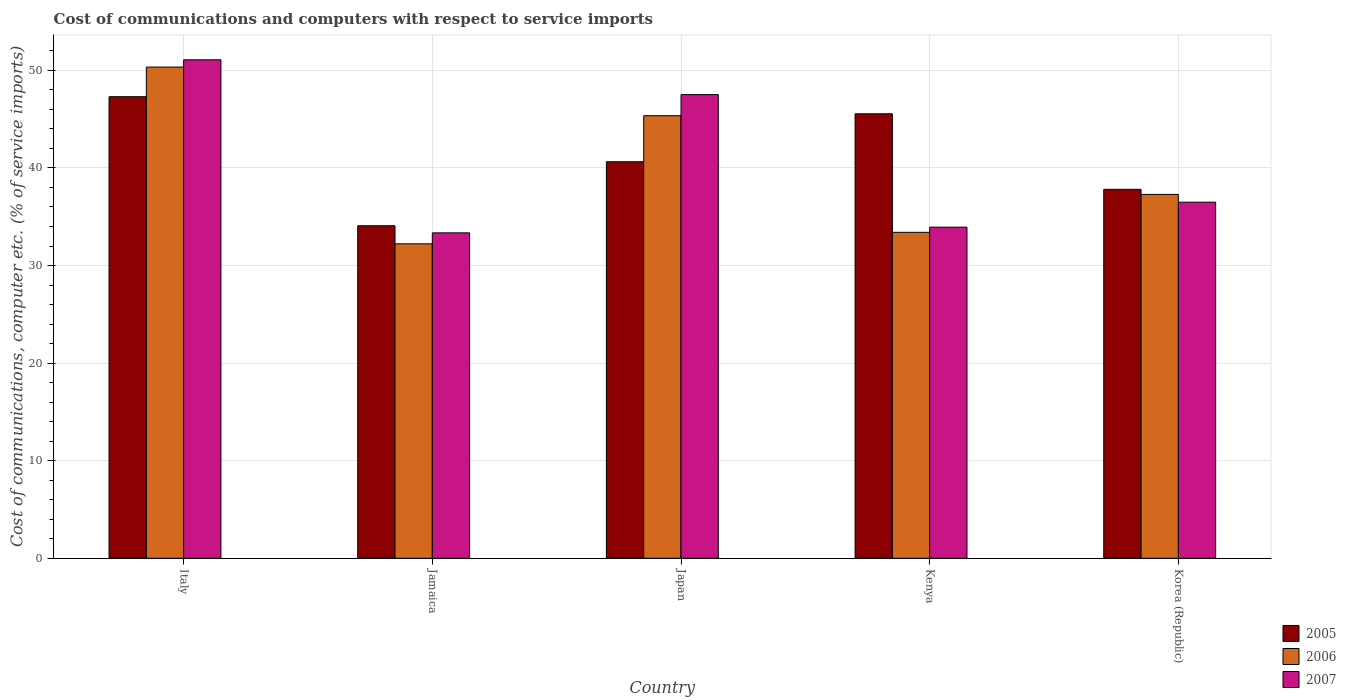Are the number of bars per tick equal to the number of legend labels?
Provide a short and direct response. Yes. How many bars are there on the 2nd tick from the left?
Your answer should be compact. 3. How many bars are there on the 4th tick from the right?
Your response must be concise. 3. What is the label of the 2nd group of bars from the left?
Keep it short and to the point. Jamaica. What is the cost of communications and computers in 2007 in Korea (Republic)?
Offer a very short reply. 36.49. Across all countries, what is the maximum cost of communications and computers in 2007?
Make the answer very short. 51.08. Across all countries, what is the minimum cost of communications and computers in 2006?
Ensure brevity in your answer.  32.23. In which country was the cost of communications and computers in 2007 minimum?
Your response must be concise. Jamaica. What is the total cost of communications and computers in 2006 in the graph?
Offer a very short reply. 198.61. What is the difference between the cost of communications and computers in 2007 in Kenya and that in Korea (Republic)?
Ensure brevity in your answer.  -2.56. What is the difference between the cost of communications and computers in 2007 in Kenya and the cost of communications and computers in 2006 in Japan?
Keep it short and to the point. -11.42. What is the average cost of communications and computers in 2006 per country?
Provide a succinct answer. 39.72. What is the difference between the cost of communications and computers of/in 2007 and cost of communications and computers of/in 2006 in Jamaica?
Provide a short and direct response. 1.12. What is the ratio of the cost of communications and computers in 2006 in Jamaica to that in Japan?
Make the answer very short. 0.71. Is the difference between the cost of communications and computers in 2007 in Japan and Korea (Republic) greater than the difference between the cost of communications and computers in 2006 in Japan and Korea (Republic)?
Keep it short and to the point. Yes. What is the difference between the highest and the second highest cost of communications and computers in 2005?
Provide a short and direct response. -4.91. What is the difference between the highest and the lowest cost of communications and computers in 2006?
Your response must be concise. 18.11. In how many countries, is the cost of communications and computers in 2006 greater than the average cost of communications and computers in 2006 taken over all countries?
Your answer should be compact. 2. Is the sum of the cost of communications and computers in 2006 in Japan and Kenya greater than the maximum cost of communications and computers in 2005 across all countries?
Ensure brevity in your answer.  Yes. What does the 2nd bar from the left in Italy represents?
Give a very brief answer. 2006. What does the 2nd bar from the right in Korea (Republic) represents?
Keep it short and to the point. 2006. Is it the case that in every country, the sum of the cost of communications and computers in 2007 and cost of communications and computers in 2005 is greater than the cost of communications and computers in 2006?
Make the answer very short. Yes. Are all the bars in the graph horizontal?
Keep it short and to the point. No. How many countries are there in the graph?
Offer a terse response. 5. Does the graph contain grids?
Offer a very short reply. Yes. Where does the legend appear in the graph?
Your answer should be very brief. Bottom right. How are the legend labels stacked?
Keep it short and to the point. Vertical. What is the title of the graph?
Your response must be concise. Cost of communications and computers with respect to service imports. What is the label or title of the X-axis?
Your answer should be very brief. Country. What is the label or title of the Y-axis?
Keep it short and to the point. Cost of communications, computer etc. (% of service imports). What is the Cost of communications, computer etc. (% of service imports) in 2005 in Italy?
Your answer should be very brief. 47.3. What is the Cost of communications, computer etc. (% of service imports) of 2006 in Italy?
Keep it short and to the point. 50.34. What is the Cost of communications, computer etc. (% of service imports) of 2007 in Italy?
Keep it short and to the point. 51.08. What is the Cost of communications, computer etc. (% of service imports) in 2005 in Jamaica?
Offer a terse response. 34.08. What is the Cost of communications, computer etc. (% of service imports) in 2006 in Jamaica?
Keep it short and to the point. 32.23. What is the Cost of communications, computer etc. (% of service imports) of 2007 in Jamaica?
Offer a terse response. 33.35. What is the Cost of communications, computer etc. (% of service imports) of 2005 in Japan?
Give a very brief answer. 40.64. What is the Cost of communications, computer etc. (% of service imports) of 2006 in Japan?
Provide a succinct answer. 45.36. What is the Cost of communications, computer etc. (% of service imports) in 2007 in Japan?
Offer a terse response. 47.52. What is the Cost of communications, computer etc. (% of service imports) of 2005 in Kenya?
Provide a short and direct response. 45.55. What is the Cost of communications, computer etc. (% of service imports) in 2006 in Kenya?
Make the answer very short. 33.4. What is the Cost of communications, computer etc. (% of service imports) of 2007 in Kenya?
Your answer should be compact. 33.93. What is the Cost of communications, computer etc. (% of service imports) in 2005 in Korea (Republic)?
Your answer should be compact. 37.81. What is the Cost of communications, computer etc. (% of service imports) of 2006 in Korea (Republic)?
Offer a very short reply. 37.29. What is the Cost of communications, computer etc. (% of service imports) of 2007 in Korea (Republic)?
Offer a terse response. 36.49. Across all countries, what is the maximum Cost of communications, computer etc. (% of service imports) of 2005?
Offer a very short reply. 47.3. Across all countries, what is the maximum Cost of communications, computer etc. (% of service imports) of 2006?
Offer a very short reply. 50.34. Across all countries, what is the maximum Cost of communications, computer etc. (% of service imports) of 2007?
Keep it short and to the point. 51.08. Across all countries, what is the minimum Cost of communications, computer etc. (% of service imports) in 2005?
Your answer should be compact. 34.08. Across all countries, what is the minimum Cost of communications, computer etc. (% of service imports) of 2006?
Ensure brevity in your answer.  32.23. Across all countries, what is the minimum Cost of communications, computer etc. (% of service imports) of 2007?
Make the answer very short. 33.35. What is the total Cost of communications, computer etc. (% of service imports) of 2005 in the graph?
Your answer should be very brief. 205.38. What is the total Cost of communications, computer etc. (% of service imports) of 2006 in the graph?
Make the answer very short. 198.61. What is the total Cost of communications, computer etc. (% of service imports) in 2007 in the graph?
Offer a very short reply. 202.38. What is the difference between the Cost of communications, computer etc. (% of service imports) in 2005 in Italy and that in Jamaica?
Your answer should be very brief. 13.22. What is the difference between the Cost of communications, computer etc. (% of service imports) of 2006 in Italy and that in Jamaica?
Give a very brief answer. 18.11. What is the difference between the Cost of communications, computer etc. (% of service imports) of 2007 in Italy and that in Jamaica?
Ensure brevity in your answer.  17.74. What is the difference between the Cost of communications, computer etc. (% of service imports) of 2005 in Italy and that in Japan?
Provide a short and direct response. 6.66. What is the difference between the Cost of communications, computer etc. (% of service imports) of 2006 in Italy and that in Japan?
Provide a short and direct response. 4.98. What is the difference between the Cost of communications, computer etc. (% of service imports) of 2007 in Italy and that in Japan?
Ensure brevity in your answer.  3.57. What is the difference between the Cost of communications, computer etc. (% of service imports) of 2005 in Italy and that in Kenya?
Make the answer very short. 1.75. What is the difference between the Cost of communications, computer etc. (% of service imports) of 2006 in Italy and that in Kenya?
Offer a terse response. 16.93. What is the difference between the Cost of communications, computer etc. (% of service imports) of 2007 in Italy and that in Kenya?
Ensure brevity in your answer.  17.15. What is the difference between the Cost of communications, computer etc. (% of service imports) of 2005 in Italy and that in Korea (Republic)?
Give a very brief answer. 9.49. What is the difference between the Cost of communications, computer etc. (% of service imports) of 2006 in Italy and that in Korea (Republic)?
Ensure brevity in your answer.  13.05. What is the difference between the Cost of communications, computer etc. (% of service imports) in 2007 in Italy and that in Korea (Republic)?
Keep it short and to the point. 14.59. What is the difference between the Cost of communications, computer etc. (% of service imports) of 2005 in Jamaica and that in Japan?
Your answer should be compact. -6.56. What is the difference between the Cost of communications, computer etc. (% of service imports) of 2006 in Jamaica and that in Japan?
Make the answer very short. -13.13. What is the difference between the Cost of communications, computer etc. (% of service imports) in 2007 in Jamaica and that in Japan?
Provide a short and direct response. -14.17. What is the difference between the Cost of communications, computer etc. (% of service imports) in 2005 in Jamaica and that in Kenya?
Keep it short and to the point. -11.47. What is the difference between the Cost of communications, computer etc. (% of service imports) in 2006 in Jamaica and that in Kenya?
Make the answer very short. -1.18. What is the difference between the Cost of communications, computer etc. (% of service imports) in 2007 in Jamaica and that in Kenya?
Provide a succinct answer. -0.59. What is the difference between the Cost of communications, computer etc. (% of service imports) in 2005 in Jamaica and that in Korea (Republic)?
Provide a succinct answer. -3.73. What is the difference between the Cost of communications, computer etc. (% of service imports) of 2006 in Jamaica and that in Korea (Republic)?
Offer a terse response. -5.06. What is the difference between the Cost of communications, computer etc. (% of service imports) in 2007 in Jamaica and that in Korea (Republic)?
Your response must be concise. -3.14. What is the difference between the Cost of communications, computer etc. (% of service imports) of 2005 in Japan and that in Kenya?
Provide a succinct answer. -4.91. What is the difference between the Cost of communications, computer etc. (% of service imports) of 2006 in Japan and that in Kenya?
Offer a terse response. 11.95. What is the difference between the Cost of communications, computer etc. (% of service imports) of 2007 in Japan and that in Kenya?
Keep it short and to the point. 13.58. What is the difference between the Cost of communications, computer etc. (% of service imports) in 2005 in Japan and that in Korea (Republic)?
Give a very brief answer. 2.83. What is the difference between the Cost of communications, computer etc. (% of service imports) of 2006 in Japan and that in Korea (Republic)?
Provide a short and direct response. 8.07. What is the difference between the Cost of communications, computer etc. (% of service imports) in 2007 in Japan and that in Korea (Republic)?
Give a very brief answer. 11.03. What is the difference between the Cost of communications, computer etc. (% of service imports) of 2005 in Kenya and that in Korea (Republic)?
Make the answer very short. 7.74. What is the difference between the Cost of communications, computer etc. (% of service imports) of 2006 in Kenya and that in Korea (Republic)?
Give a very brief answer. -3.88. What is the difference between the Cost of communications, computer etc. (% of service imports) in 2007 in Kenya and that in Korea (Republic)?
Your answer should be very brief. -2.56. What is the difference between the Cost of communications, computer etc. (% of service imports) of 2005 in Italy and the Cost of communications, computer etc. (% of service imports) of 2006 in Jamaica?
Provide a short and direct response. 15.08. What is the difference between the Cost of communications, computer etc. (% of service imports) of 2005 in Italy and the Cost of communications, computer etc. (% of service imports) of 2007 in Jamaica?
Your response must be concise. 13.95. What is the difference between the Cost of communications, computer etc. (% of service imports) in 2006 in Italy and the Cost of communications, computer etc. (% of service imports) in 2007 in Jamaica?
Ensure brevity in your answer.  16.99. What is the difference between the Cost of communications, computer etc. (% of service imports) in 2005 in Italy and the Cost of communications, computer etc. (% of service imports) in 2006 in Japan?
Give a very brief answer. 1.95. What is the difference between the Cost of communications, computer etc. (% of service imports) of 2005 in Italy and the Cost of communications, computer etc. (% of service imports) of 2007 in Japan?
Keep it short and to the point. -0.22. What is the difference between the Cost of communications, computer etc. (% of service imports) of 2006 in Italy and the Cost of communications, computer etc. (% of service imports) of 2007 in Japan?
Make the answer very short. 2.82. What is the difference between the Cost of communications, computer etc. (% of service imports) in 2005 in Italy and the Cost of communications, computer etc. (% of service imports) in 2006 in Kenya?
Give a very brief answer. 13.9. What is the difference between the Cost of communications, computer etc. (% of service imports) of 2005 in Italy and the Cost of communications, computer etc. (% of service imports) of 2007 in Kenya?
Your answer should be compact. 13.37. What is the difference between the Cost of communications, computer etc. (% of service imports) in 2006 in Italy and the Cost of communications, computer etc. (% of service imports) in 2007 in Kenya?
Your answer should be compact. 16.4. What is the difference between the Cost of communications, computer etc. (% of service imports) of 2005 in Italy and the Cost of communications, computer etc. (% of service imports) of 2006 in Korea (Republic)?
Your answer should be very brief. 10.01. What is the difference between the Cost of communications, computer etc. (% of service imports) in 2005 in Italy and the Cost of communications, computer etc. (% of service imports) in 2007 in Korea (Republic)?
Provide a short and direct response. 10.81. What is the difference between the Cost of communications, computer etc. (% of service imports) of 2006 in Italy and the Cost of communications, computer etc. (% of service imports) of 2007 in Korea (Republic)?
Offer a terse response. 13.85. What is the difference between the Cost of communications, computer etc. (% of service imports) in 2005 in Jamaica and the Cost of communications, computer etc. (% of service imports) in 2006 in Japan?
Keep it short and to the point. -11.28. What is the difference between the Cost of communications, computer etc. (% of service imports) in 2005 in Jamaica and the Cost of communications, computer etc. (% of service imports) in 2007 in Japan?
Ensure brevity in your answer.  -13.44. What is the difference between the Cost of communications, computer etc. (% of service imports) in 2006 in Jamaica and the Cost of communications, computer etc. (% of service imports) in 2007 in Japan?
Make the answer very short. -15.29. What is the difference between the Cost of communications, computer etc. (% of service imports) in 2005 in Jamaica and the Cost of communications, computer etc. (% of service imports) in 2006 in Kenya?
Offer a terse response. 0.67. What is the difference between the Cost of communications, computer etc. (% of service imports) of 2005 in Jamaica and the Cost of communications, computer etc. (% of service imports) of 2007 in Kenya?
Offer a terse response. 0.14. What is the difference between the Cost of communications, computer etc. (% of service imports) in 2006 in Jamaica and the Cost of communications, computer etc. (% of service imports) in 2007 in Kenya?
Make the answer very short. -1.71. What is the difference between the Cost of communications, computer etc. (% of service imports) of 2005 in Jamaica and the Cost of communications, computer etc. (% of service imports) of 2006 in Korea (Republic)?
Your answer should be very brief. -3.21. What is the difference between the Cost of communications, computer etc. (% of service imports) in 2005 in Jamaica and the Cost of communications, computer etc. (% of service imports) in 2007 in Korea (Republic)?
Keep it short and to the point. -2.42. What is the difference between the Cost of communications, computer etc. (% of service imports) in 2006 in Jamaica and the Cost of communications, computer etc. (% of service imports) in 2007 in Korea (Republic)?
Keep it short and to the point. -4.27. What is the difference between the Cost of communications, computer etc. (% of service imports) in 2005 in Japan and the Cost of communications, computer etc. (% of service imports) in 2006 in Kenya?
Offer a terse response. 7.23. What is the difference between the Cost of communications, computer etc. (% of service imports) in 2005 in Japan and the Cost of communications, computer etc. (% of service imports) in 2007 in Kenya?
Give a very brief answer. 6.7. What is the difference between the Cost of communications, computer etc. (% of service imports) of 2006 in Japan and the Cost of communications, computer etc. (% of service imports) of 2007 in Kenya?
Keep it short and to the point. 11.42. What is the difference between the Cost of communications, computer etc. (% of service imports) of 2005 in Japan and the Cost of communications, computer etc. (% of service imports) of 2006 in Korea (Republic)?
Provide a succinct answer. 3.35. What is the difference between the Cost of communications, computer etc. (% of service imports) in 2005 in Japan and the Cost of communications, computer etc. (% of service imports) in 2007 in Korea (Republic)?
Offer a very short reply. 4.14. What is the difference between the Cost of communications, computer etc. (% of service imports) in 2006 in Japan and the Cost of communications, computer etc. (% of service imports) in 2007 in Korea (Republic)?
Keep it short and to the point. 8.86. What is the difference between the Cost of communications, computer etc. (% of service imports) of 2005 in Kenya and the Cost of communications, computer etc. (% of service imports) of 2006 in Korea (Republic)?
Give a very brief answer. 8.26. What is the difference between the Cost of communications, computer etc. (% of service imports) of 2005 in Kenya and the Cost of communications, computer etc. (% of service imports) of 2007 in Korea (Republic)?
Your answer should be compact. 9.06. What is the difference between the Cost of communications, computer etc. (% of service imports) of 2006 in Kenya and the Cost of communications, computer etc. (% of service imports) of 2007 in Korea (Republic)?
Ensure brevity in your answer.  -3.09. What is the average Cost of communications, computer etc. (% of service imports) of 2005 per country?
Give a very brief answer. 41.08. What is the average Cost of communications, computer etc. (% of service imports) in 2006 per country?
Your answer should be very brief. 39.72. What is the average Cost of communications, computer etc. (% of service imports) in 2007 per country?
Offer a terse response. 40.48. What is the difference between the Cost of communications, computer etc. (% of service imports) of 2005 and Cost of communications, computer etc. (% of service imports) of 2006 in Italy?
Offer a very short reply. -3.04. What is the difference between the Cost of communications, computer etc. (% of service imports) of 2005 and Cost of communications, computer etc. (% of service imports) of 2007 in Italy?
Your answer should be very brief. -3.78. What is the difference between the Cost of communications, computer etc. (% of service imports) of 2006 and Cost of communications, computer etc. (% of service imports) of 2007 in Italy?
Provide a succinct answer. -0.75. What is the difference between the Cost of communications, computer etc. (% of service imports) of 2005 and Cost of communications, computer etc. (% of service imports) of 2006 in Jamaica?
Make the answer very short. 1.85. What is the difference between the Cost of communications, computer etc. (% of service imports) in 2005 and Cost of communications, computer etc. (% of service imports) in 2007 in Jamaica?
Make the answer very short. 0.73. What is the difference between the Cost of communications, computer etc. (% of service imports) in 2006 and Cost of communications, computer etc. (% of service imports) in 2007 in Jamaica?
Give a very brief answer. -1.12. What is the difference between the Cost of communications, computer etc. (% of service imports) of 2005 and Cost of communications, computer etc. (% of service imports) of 2006 in Japan?
Offer a terse response. -4.72. What is the difference between the Cost of communications, computer etc. (% of service imports) in 2005 and Cost of communications, computer etc. (% of service imports) in 2007 in Japan?
Your answer should be compact. -6.88. What is the difference between the Cost of communications, computer etc. (% of service imports) in 2006 and Cost of communications, computer etc. (% of service imports) in 2007 in Japan?
Keep it short and to the point. -2.16. What is the difference between the Cost of communications, computer etc. (% of service imports) in 2005 and Cost of communications, computer etc. (% of service imports) in 2006 in Kenya?
Your answer should be compact. 12.15. What is the difference between the Cost of communications, computer etc. (% of service imports) in 2005 and Cost of communications, computer etc. (% of service imports) in 2007 in Kenya?
Your answer should be very brief. 11.62. What is the difference between the Cost of communications, computer etc. (% of service imports) of 2006 and Cost of communications, computer etc. (% of service imports) of 2007 in Kenya?
Provide a succinct answer. -0.53. What is the difference between the Cost of communications, computer etc. (% of service imports) of 2005 and Cost of communications, computer etc. (% of service imports) of 2006 in Korea (Republic)?
Your response must be concise. 0.52. What is the difference between the Cost of communications, computer etc. (% of service imports) in 2005 and Cost of communications, computer etc. (% of service imports) in 2007 in Korea (Republic)?
Give a very brief answer. 1.32. What is the difference between the Cost of communications, computer etc. (% of service imports) of 2006 and Cost of communications, computer etc. (% of service imports) of 2007 in Korea (Republic)?
Your response must be concise. 0.8. What is the ratio of the Cost of communications, computer etc. (% of service imports) in 2005 in Italy to that in Jamaica?
Offer a terse response. 1.39. What is the ratio of the Cost of communications, computer etc. (% of service imports) in 2006 in Italy to that in Jamaica?
Ensure brevity in your answer.  1.56. What is the ratio of the Cost of communications, computer etc. (% of service imports) in 2007 in Italy to that in Jamaica?
Offer a very short reply. 1.53. What is the ratio of the Cost of communications, computer etc. (% of service imports) in 2005 in Italy to that in Japan?
Your answer should be very brief. 1.16. What is the ratio of the Cost of communications, computer etc. (% of service imports) in 2006 in Italy to that in Japan?
Ensure brevity in your answer.  1.11. What is the ratio of the Cost of communications, computer etc. (% of service imports) of 2007 in Italy to that in Japan?
Make the answer very short. 1.07. What is the ratio of the Cost of communications, computer etc. (% of service imports) of 2005 in Italy to that in Kenya?
Your answer should be very brief. 1.04. What is the ratio of the Cost of communications, computer etc. (% of service imports) in 2006 in Italy to that in Kenya?
Provide a succinct answer. 1.51. What is the ratio of the Cost of communications, computer etc. (% of service imports) in 2007 in Italy to that in Kenya?
Provide a short and direct response. 1.51. What is the ratio of the Cost of communications, computer etc. (% of service imports) in 2005 in Italy to that in Korea (Republic)?
Give a very brief answer. 1.25. What is the ratio of the Cost of communications, computer etc. (% of service imports) in 2006 in Italy to that in Korea (Republic)?
Keep it short and to the point. 1.35. What is the ratio of the Cost of communications, computer etc. (% of service imports) in 2007 in Italy to that in Korea (Republic)?
Offer a very short reply. 1.4. What is the ratio of the Cost of communications, computer etc. (% of service imports) in 2005 in Jamaica to that in Japan?
Offer a terse response. 0.84. What is the ratio of the Cost of communications, computer etc. (% of service imports) of 2006 in Jamaica to that in Japan?
Ensure brevity in your answer.  0.71. What is the ratio of the Cost of communications, computer etc. (% of service imports) of 2007 in Jamaica to that in Japan?
Make the answer very short. 0.7. What is the ratio of the Cost of communications, computer etc. (% of service imports) in 2005 in Jamaica to that in Kenya?
Make the answer very short. 0.75. What is the ratio of the Cost of communications, computer etc. (% of service imports) in 2006 in Jamaica to that in Kenya?
Make the answer very short. 0.96. What is the ratio of the Cost of communications, computer etc. (% of service imports) in 2007 in Jamaica to that in Kenya?
Make the answer very short. 0.98. What is the ratio of the Cost of communications, computer etc. (% of service imports) in 2005 in Jamaica to that in Korea (Republic)?
Give a very brief answer. 0.9. What is the ratio of the Cost of communications, computer etc. (% of service imports) in 2006 in Jamaica to that in Korea (Republic)?
Give a very brief answer. 0.86. What is the ratio of the Cost of communications, computer etc. (% of service imports) in 2007 in Jamaica to that in Korea (Republic)?
Ensure brevity in your answer.  0.91. What is the ratio of the Cost of communications, computer etc. (% of service imports) in 2005 in Japan to that in Kenya?
Make the answer very short. 0.89. What is the ratio of the Cost of communications, computer etc. (% of service imports) in 2006 in Japan to that in Kenya?
Make the answer very short. 1.36. What is the ratio of the Cost of communications, computer etc. (% of service imports) of 2007 in Japan to that in Kenya?
Provide a succinct answer. 1.4. What is the ratio of the Cost of communications, computer etc. (% of service imports) in 2005 in Japan to that in Korea (Republic)?
Offer a very short reply. 1.07. What is the ratio of the Cost of communications, computer etc. (% of service imports) of 2006 in Japan to that in Korea (Republic)?
Provide a succinct answer. 1.22. What is the ratio of the Cost of communications, computer etc. (% of service imports) of 2007 in Japan to that in Korea (Republic)?
Offer a terse response. 1.3. What is the ratio of the Cost of communications, computer etc. (% of service imports) in 2005 in Kenya to that in Korea (Republic)?
Provide a short and direct response. 1.2. What is the ratio of the Cost of communications, computer etc. (% of service imports) of 2006 in Kenya to that in Korea (Republic)?
Offer a terse response. 0.9. What is the ratio of the Cost of communications, computer etc. (% of service imports) of 2007 in Kenya to that in Korea (Republic)?
Keep it short and to the point. 0.93. What is the difference between the highest and the second highest Cost of communications, computer etc. (% of service imports) in 2005?
Your response must be concise. 1.75. What is the difference between the highest and the second highest Cost of communications, computer etc. (% of service imports) of 2006?
Offer a terse response. 4.98. What is the difference between the highest and the second highest Cost of communications, computer etc. (% of service imports) of 2007?
Your answer should be compact. 3.57. What is the difference between the highest and the lowest Cost of communications, computer etc. (% of service imports) of 2005?
Your answer should be compact. 13.22. What is the difference between the highest and the lowest Cost of communications, computer etc. (% of service imports) of 2006?
Provide a short and direct response. 18.11. What is the difference between the highest and the lowest Cost of communications, computer etc. (% of service imports) in 2007?
Ensure brevity in your answer.  17.74. 